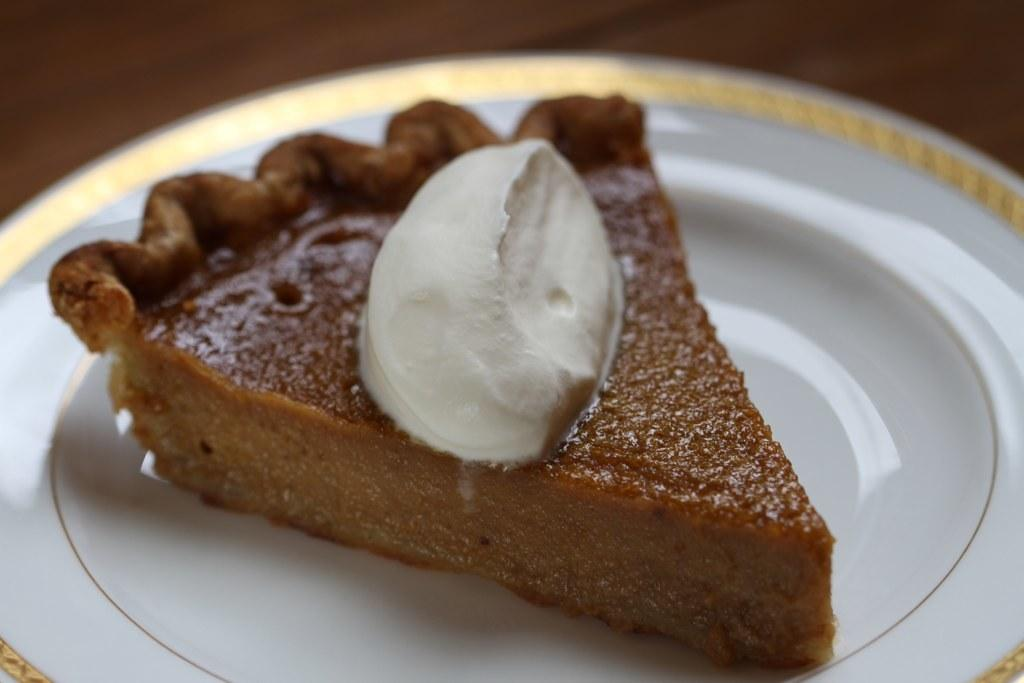What is on the plate that is visible in the image? There is a piece of cake on the plate in the image. What is the color of the plate? The plate is white. What is on top of the cake? There is cream on the cake. What is the plate resting on in the image? The plate is on an object, but the specific object is not mentioned in the facts. What type of government is depicted in the image? There is no reference to a government in the image; it features a plate with a piece of cake and cream. Can you see any planes in the image? There are no planes visible in the image. 